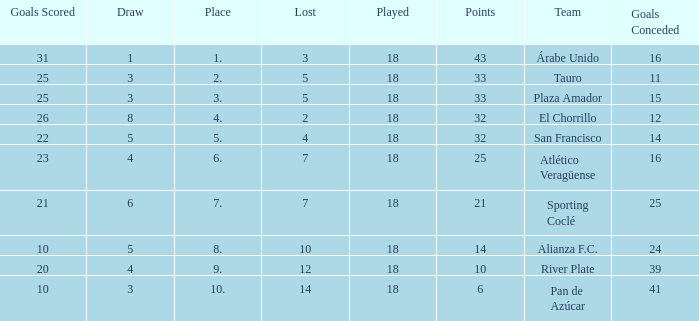How many goals were conceded by teams with 32 points, more than 2 losses and more than 22 goals scored? 0.0. 